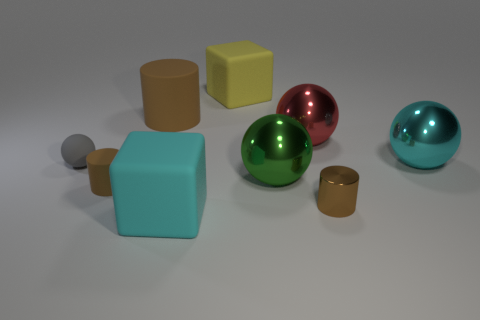Is the material of the cyan ball the same as the yellow thing? The material looks different upon closer observation. The cyan object appears to be a glossy ball, while the yellow object has a matte finish and is cube-shaped, suggesting they are made of different substances. 